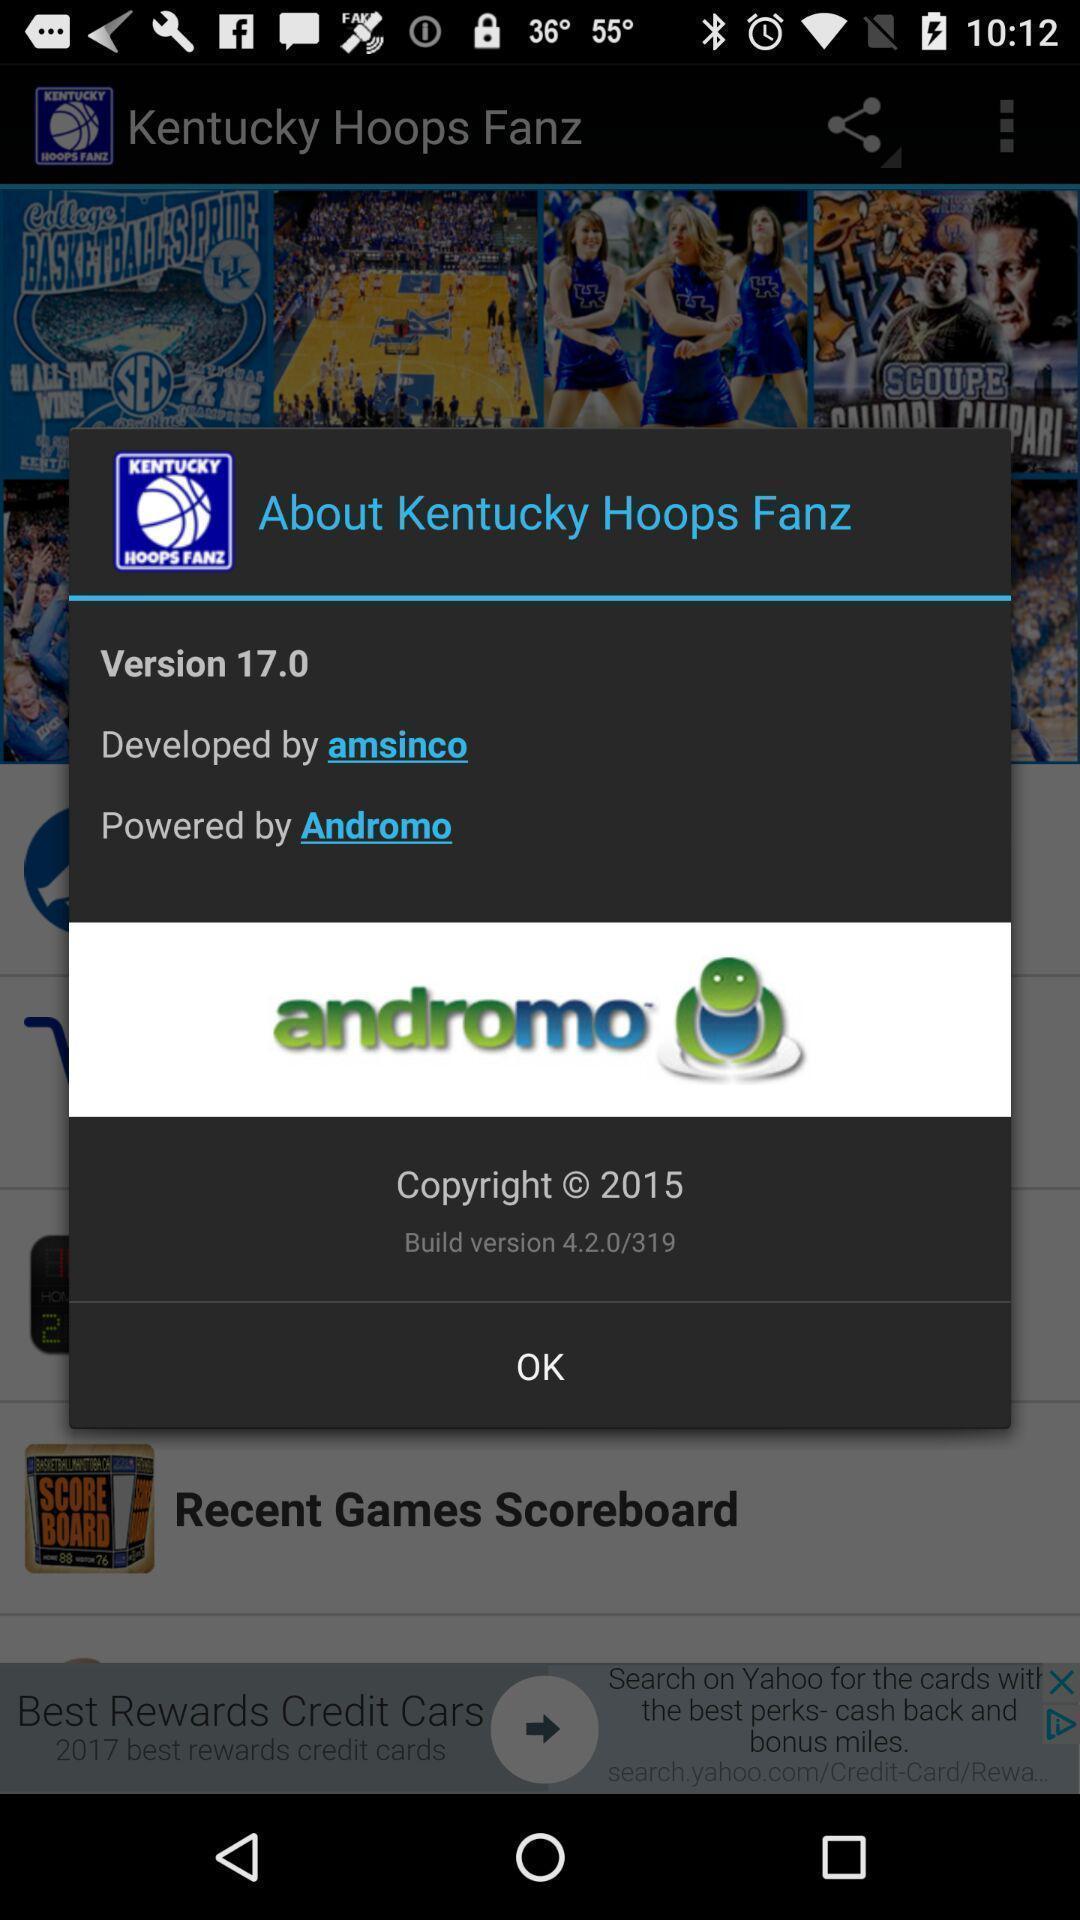Tell me what you see in this picture. Popup for the sports streaming app. 